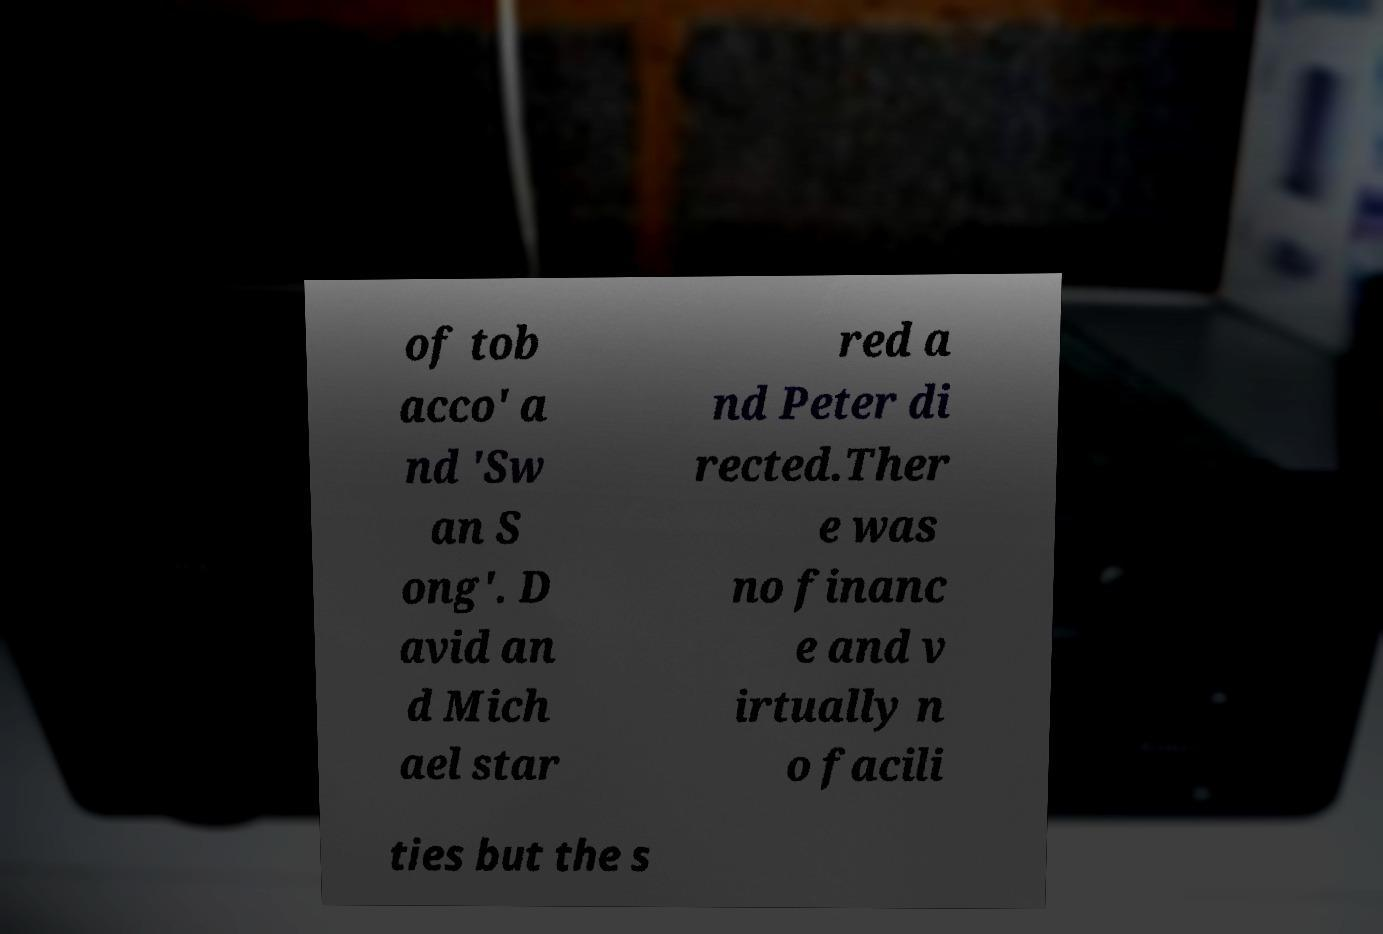Could you assist in decoding the text presented in this image and type it out clearly? of tob acco' a nd 'Sw an S ong'. D avid an d Mich ael star red a nd Peter di rected.Ther e was no financ e and v irtually n o facili ties but the s 